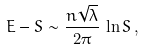Convert formula to latex. <formula><loc_0><loc_0><loc_500><loc_500>E - S \sim \frac { n \sqrt { \lambda } } { 2 \pi } \, \ln S \, ,</formula> 